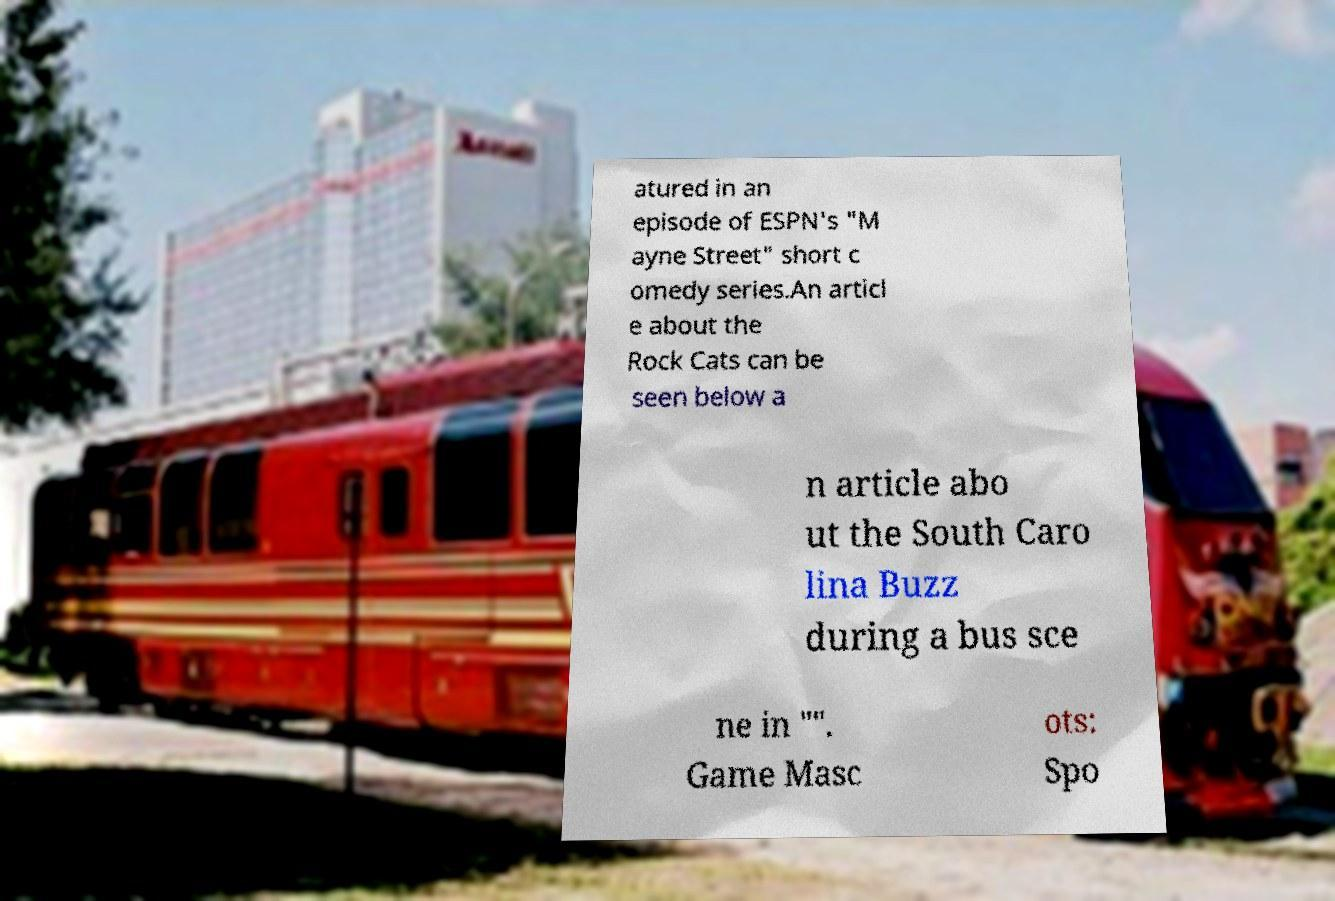Please read and relay the text visible in this image. What does it say? atured in an episode of ESPN's "M ayne Street" short c omedy series.An articl e about the Rock Cats can be seen below a n article abo ut the South Caro lina Buzz during a bus sce ne in "". Game Masc ots: Spo 